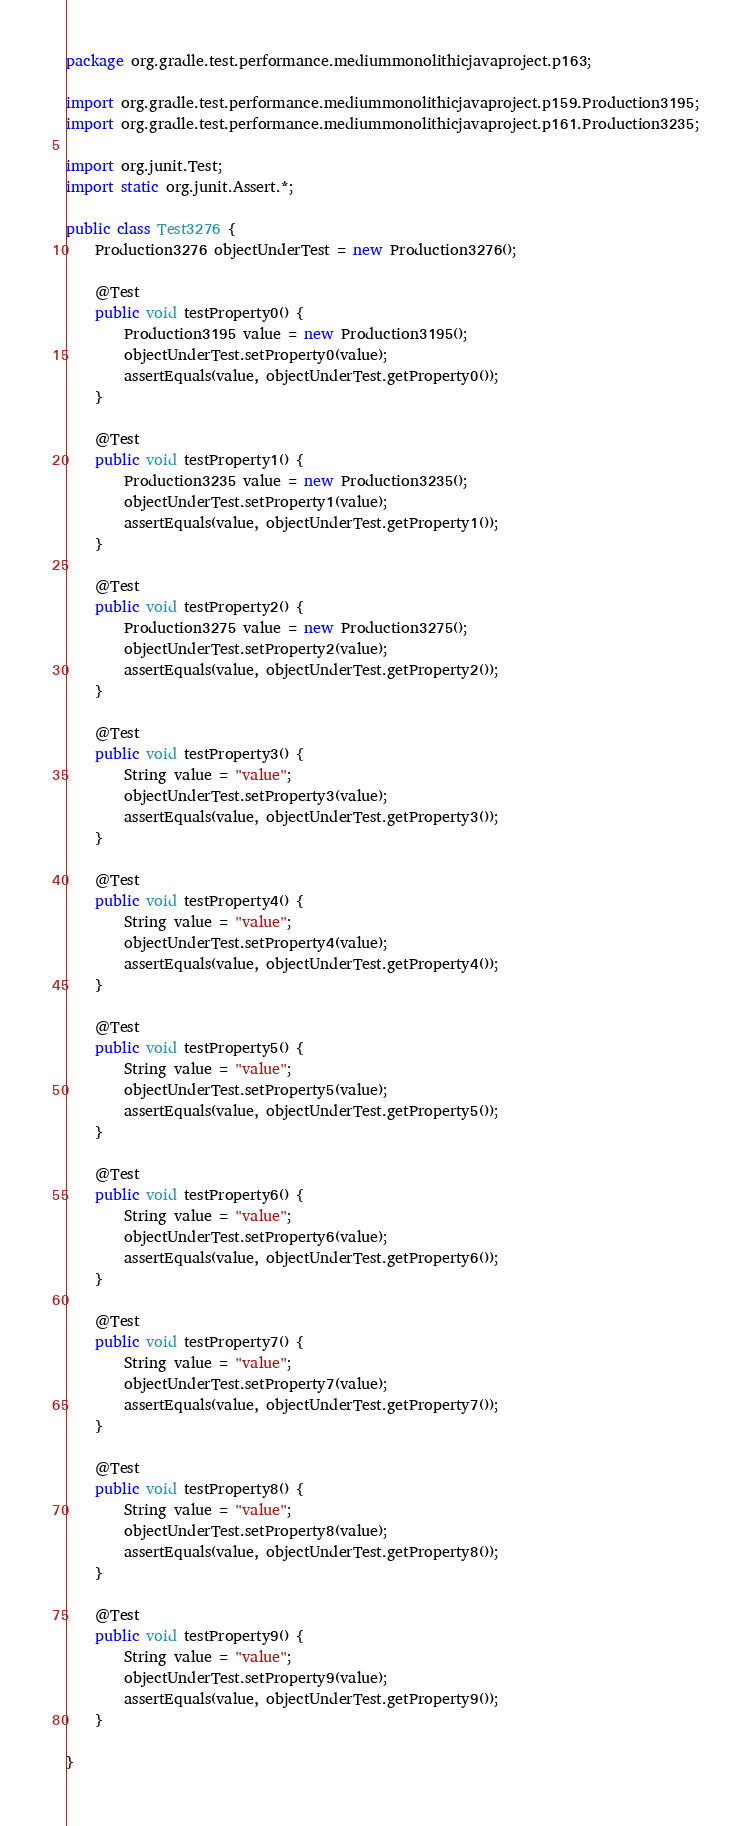<code> <loc_0><loc_0><loc_500><loc_500><_Java_>package org.gradle.test.performance.mediummonolithicjavaproject.p163;

import org.gradle.test.performance.mediummonolithicjavaproject.p159.Production3195;
import org.gradle.test.performance.mediummonolithicjavaproject.p161.Production3235;

import org.junit.Test;
import static org.junit.Assert.*;

public class Test3276 {  
    Production3276 objectUnderTest = new Production3276();     

    @Test
    public void testProperty0() {
        Production3195 value = new Production3195();
        objectUnderTest.setProperty0(value);
        assertEquals(value, objectUnderTest.getProperty0());
    }

    @Test
    public void testProperty1() {
        Production3235 value = new Production3235();
        objectUnderTest.setProperty1(value);
        assertEquals(value, objectUnderTest.getProperty1());
    }

    @Test
    public void testProperty2() {
        Production3275 value = new Production3275();
        objectUnderTest.setProperty2(value);
        assertEquals(value, objectUnderTest.getProperty2());
    }

    @Test
    public void testProperty3() {
        String value = "value";
        objectUnderTest.setProperty3(value);
        assertEquals(value, objectUnderTest.getProperty3());
    }

    @Test
    public void testProperty4() {
        String value = "value";
        objectUnderTest.setProperty4(value);
        assertEquals(value, objectUnderTest.getProperty4());
    }

    @Test
    public void testProperty5() {
        String value = "value";
        objectUnderTest.setProperty5(value);
        assertEquals(value, objectUnderTest.getProperty5());
    }

    @Test
    public void testProperty6() {
        String value = "value";
        objectUnderTest.setProperty6(value);
        assertEquals(value, objectUnderTest.getProperty6());
    }

    @Test
    public void testProperty7() {
        String value = "value";
        objectUnderTest.setProperty7(value);
        assertEquals(value, objectUnderTest.getProperty7());
    }

    @Test
    public void testProperty8() {
        String value = "value";
        objectUnderTest.setProperty8(value);
        assertEquals(value, objectUnderTest.getProperty8());
    }

    @Test
    public void testProperty9() {
        String value = "value";
        objectUnderTest.setProperty9(value);
        assertEquals(value, objectUnderTest.getProperty9());
    }

}</code> 